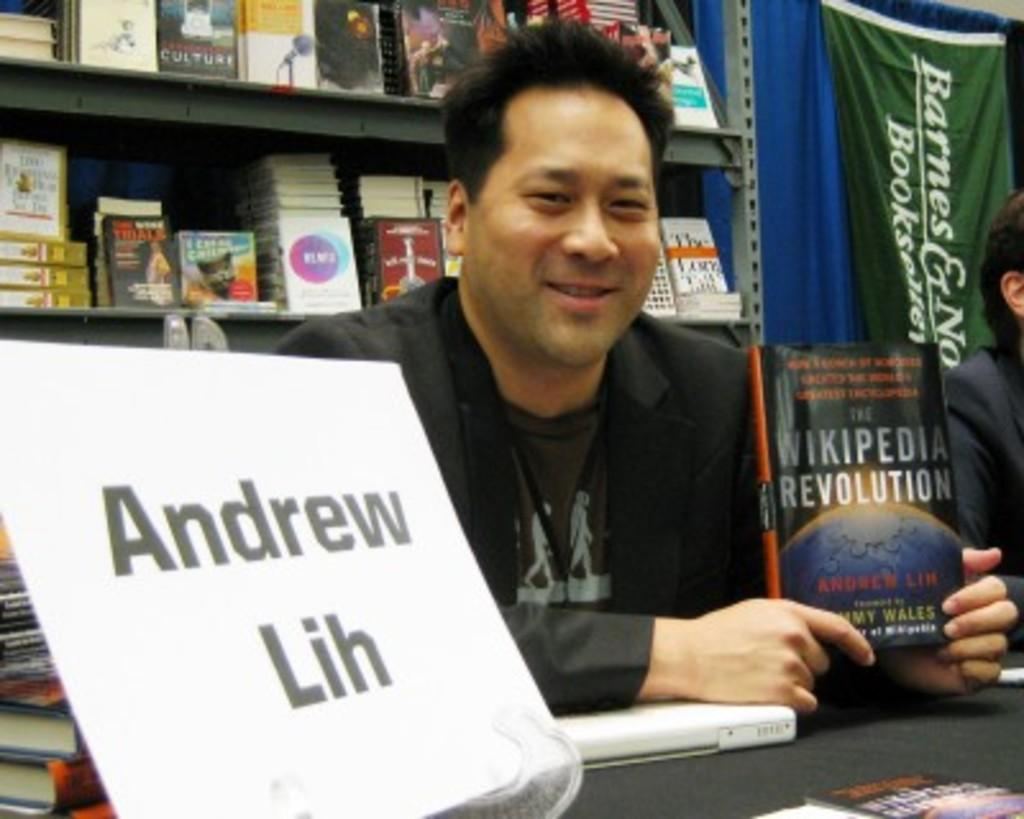<image>
Summarize the visual content of the image. Andrew Lin holding up his book the Wikipedia Revolution 